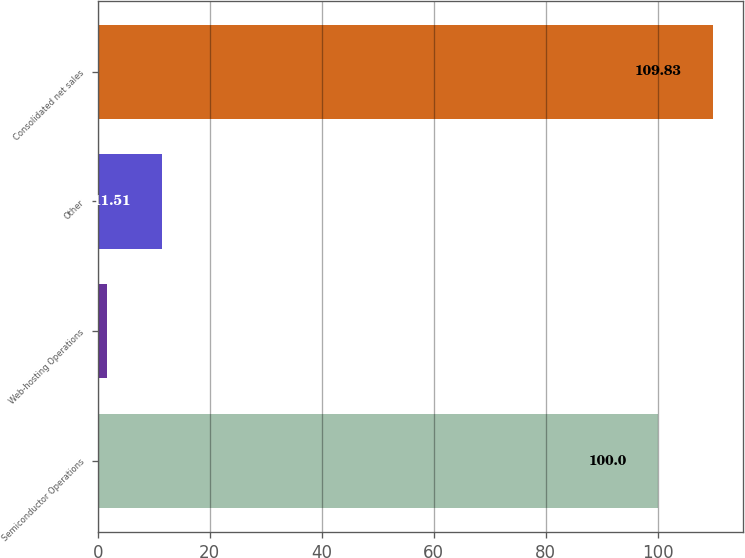<chart> <loc_0><loc_0><loc_500><loc_500><bar_chart><fcel>Semiconductor Operations<fcel>Web-hosting Operations<fcel>Other<fcel>Consolidated net sales<nl><fcel>100<fcel>1.68<fcel>11.51<fcel>109.83<nl></chart> 